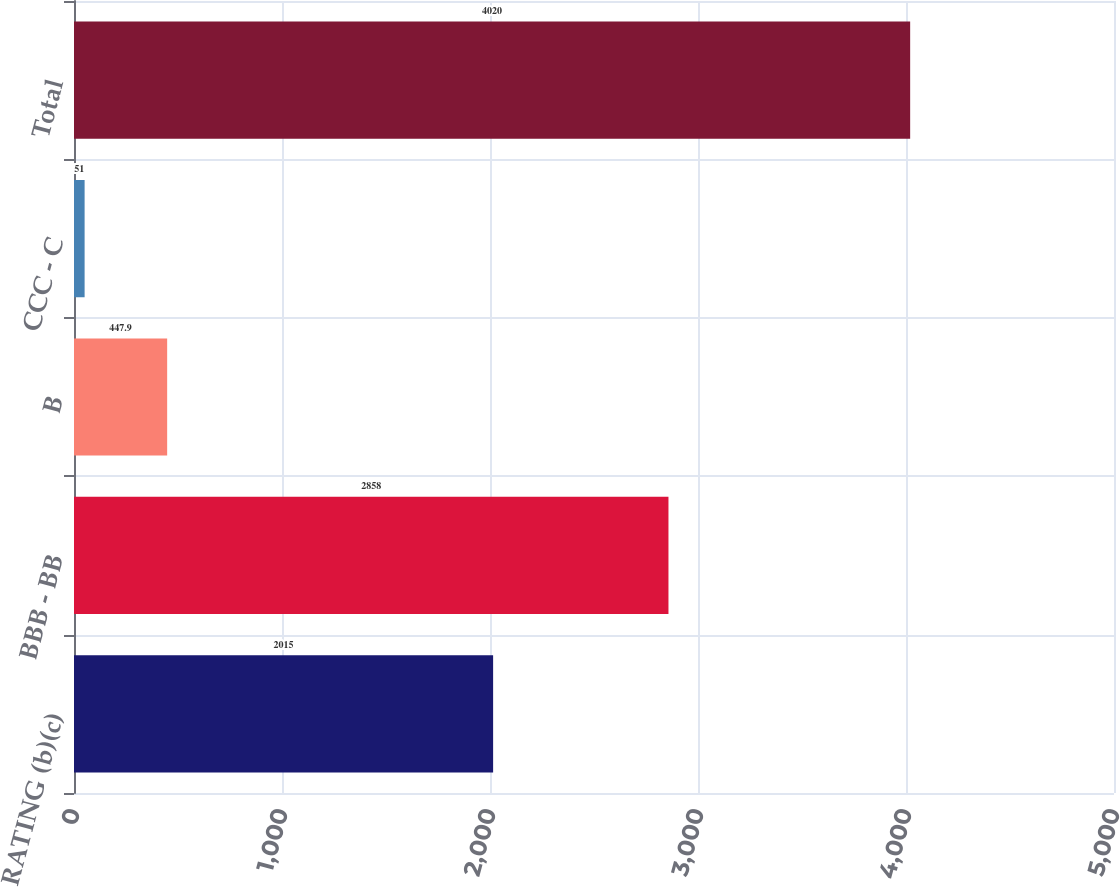Convert chart to OTSL. <chart><loc_0><loc_0><loc_500><loc_500><bar_chart><fcel>RATING (b)(c)<fcel>BBB - BB<fcel>B<fcel>CCC - C<fcel>Total<nl><fcel>2015<fcel>2858<fcel>447.9<fcel>51<fcel>4020<nl></chart> 